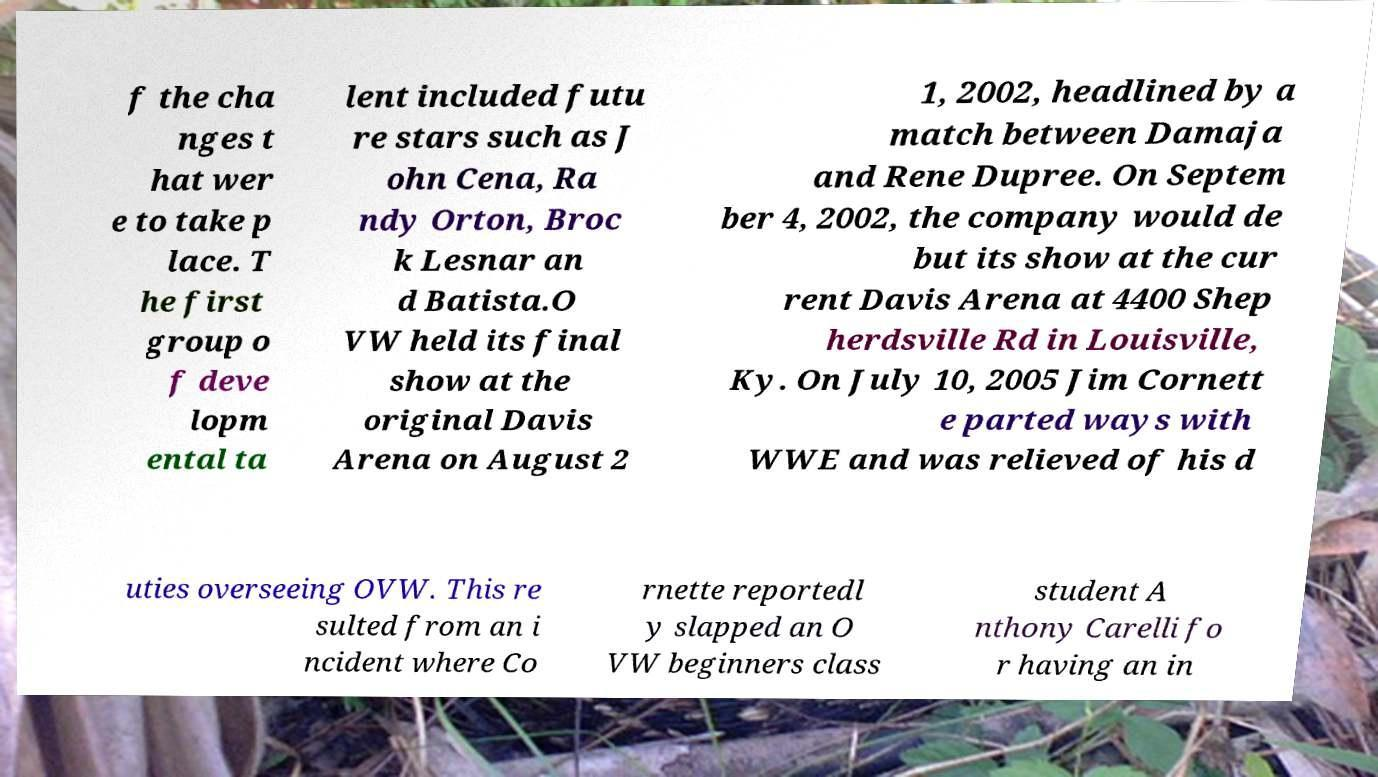I need the written content from this picture converted into text. Can you do that? f the cha nges t hat wer e to take p lace. T he first group o f deve lopm ental ta lent included futu re stars such as J ohn Cena, Ra ndy Orton, Broc k Lesnar an d Batista.O VW held its final show at the original Davis Arena on August 2 1, 2002, headlined by a match between Damaja and Rene Dupree. On Septem ber 4, 2002, the company would de but its show at the cur rent Davis Arena at 4400 Shep herdsville Rd in Louisville, Ky. On July 10, 2005 Jim Cornett e parted ways with WWE and was relieved of his d uties overseeing OVW. This re sulted from an i ncident where Co rnette reportedl y slapped an O VW beginners class student A nthony Carelli fo r having an in 